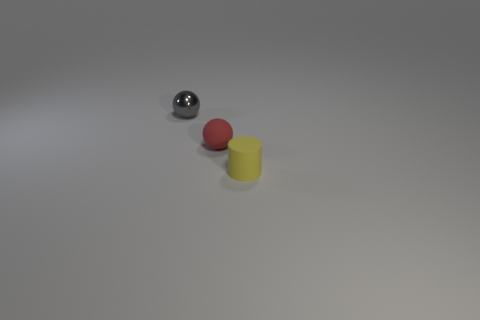There is a tiny matte object to the left of the small rubber object on the right side of the tiny rubber thing that is to the left of the small yellow rubber cylinder; what is its shape?
Your answer should be compact. Sphere. How many other things are there of the same shape as the metallic object?
Provide a succinct answer. 1. How many rubber things are either big cyan spheres or small yellow objects?
Your response must be concise. 1. There is a object that is in front of the ball that is right of the gray metallic thing; what is it made of?
Keep it short and to the point. Rubber. Is the number of things that are left of the yellow rubber thing greater than the number of cyan cylinders?
Your answer should be compact. Yes. Are there any big cyan spheres that have the same material as the tiny cylinder?
Offer a terse response. No. Does the small rubber object that is behind the yellow cylinder have the same shape as the tiny gray shiny thing?
Your response must be concise. Yes. There is a object that is in front of the small rubber object that is on the left side of the tiny yellow object; what number of small yellow cylinders are to the left of it?
Your answer should be compact. 0. Are there fewer small metal objects in front of the small yellow rubber object than small gray things that are to the right of the small red rubber thing?
Provide a succinct answer. No. There is a rubber thing that is the same shape as the small metallic object; what is its color?
Make the answer very short. Red. 